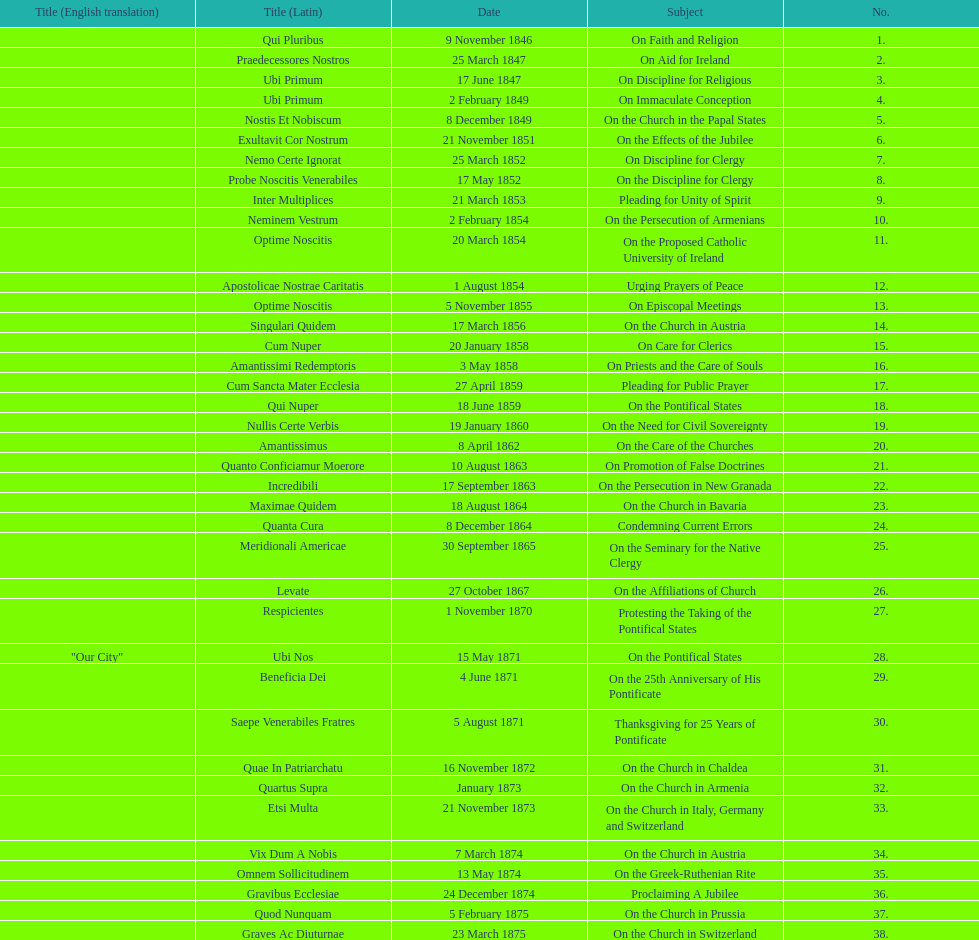Help me parse the entirety of this table. {'header': ['Title (English translation)', 'Title (Latin)', 'Date', 'Subject', 'No.'], 'rows': [['', 'Qui Pluribus', '9 November 1846', 'On Faith and Religion', '1.'], ['', 'Praedecessores Nostros', '25 March 1847', 'On Aid for Ireland', '2.'], ['', 'Ubi Primum', '17 June 1847', 'On Discipline for Religious', '3.'], ['', 'Ubi Primum', '2 February 1849', 'On Immaculate Conception', '4.'], ['', 'Nostis Et Nobiscum', '8 December 1849', 'On the Church in the Papal States', '5.'], ['', 'Exultavit Cor Nostrum', '21 November 1851', 'On the Effects of the Jubilee', '6.'], ['', 'Nemo Certe Ignorat', '25 March 1852', 'On Discipline for Clergy', '7.'], ['', 'Probe Noscitis Venerabiles', '17 May 1852', 'On the Discipline for Clergy', '8.'], ['', 'Inter Multiplices', '21 March 1853', 'Pleading for Unity of Spirit', '9.'], ['', 'Neminem Vestrum', '2 February 1854', 'On the Persecution of Armenians', '10.'], ['', 'Optime Noscitis', '20 March 1854', 'On the Proposed Catholic University of Ireland', '11.'], ['', 'Apostolicae Nostrae Caritatis', '1 August 1854', 'Urging Prayers of Peace', '12.'], ['', 'Optime Noscitis', '5 November 1855', 'On Episcopal Meetings', '13.'], ['', 'Singulari Quidem', '17 March 1856', 'On the Church in Austria', '14.'], ['', 'Cum Nuper', '20 January 1858', 'On Care for Clerics', '15.'], ['', 'Amantissimi Redemptoris', '3 May 1858', 'On Priests and the Care of Souls', '16.'], ['', 'Cum Sancta Mater Ecclesia', '27 April 1859', 'Pleading for Public Prayer', '17.'], ['', 'Qui Nuper', '18 June 1859', 'On the Pontifical States', '18.'], ['', 'Nullis Certe Verbis', '19 January 1860', 'On the Need for Civil Sovereignty', '19.'], ['', 'Amantissimus', '8 April 1862', 'On the Care of the Churches', '20.'], ['', 'Quanto Conficiamur Moerore', '10 August 1863', 'On Promotion of False Doctrines', '21.'], ['', 'Incredibili', '17 September 1863', 'On the Persecution in New Granada', '22.'], ['', 'Maximae Quidem', '18 August 1864', 'On the Church in Bavaria', '23.'], ['', 'Quanta Cura', '8 December 1864', 'Condemning Current Errors', '24.'], ['', 'Meridionali Americae', '30 September 1865', 'On the Seminary for the Native Clergy', '25.'], ['', 'Levate', '27 October 1867', 'On the Affiliations of Church', '26.'], ['', 'Respicientes', '1 November 1870', 'Protesting the Taking of the Pontifical States', '27.'], ['"Our City"', 'Ubi Nos', '15 May 1871', 'On the Pontifical States', '28.'], ['', 'Beneficia Dei', '4 June 1871', 'On the 25th Anniversary of His Pontificate', '29.'], ['', 'Saepe Venerabiles Fratres', '5 August 1871', 'Thanksgiving for 25 Years of Pontificate', '30.'], ['', 'Quae In Patriarchatu', '16 November 1872', 'On the Church in Chaldea', '31.'], ['', 'Quartus Supra', 'January 1873', 'On the Church in Armenia', '32.'], ['', 'Etsi Multa', '21 November 1873', 'On the Church in Italy, Germany and Switzerland', '33.'], ['', 'Vix Dum A Nobis', '7 March 1874', 'On the Church in Austria', '34.'], ['', 'Omnem Sollicitudinem', '13 May 1874', 'On the Greek-Ruthenian Rite', '35.'], ['', 'Gravibus Ecclesiae', '24 December 1874', 'Proclaiming A Jubilee', '36.'], ['', 'Quod Nunquam', '5 February 1875', 'On the Church in Prussia', '37.'], ['', 'Graves Ac Diuturnae', '23 March 1875', 'On the Church in Switzerland', '38.']]} How often was an encyclical sent in january? 3. 